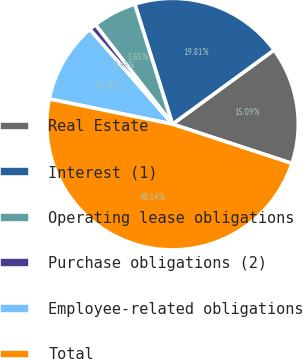Convert chart to OTSL. <chart><loc_0><loc_0><loc_500><loc_500><pie_chart><fcel>Real Estate<fcel>Interest (1)<fcel>Operating lease obligations<fcel>Purchase obligations (2)<fcel>Employee-related obligations<fcel>Total<nl><fcel>15.09%<fcel>19.81%<fcel>5.65%<fcel>0.93%<fcel>10.37%<fcel>48.14%<nl></chart> 